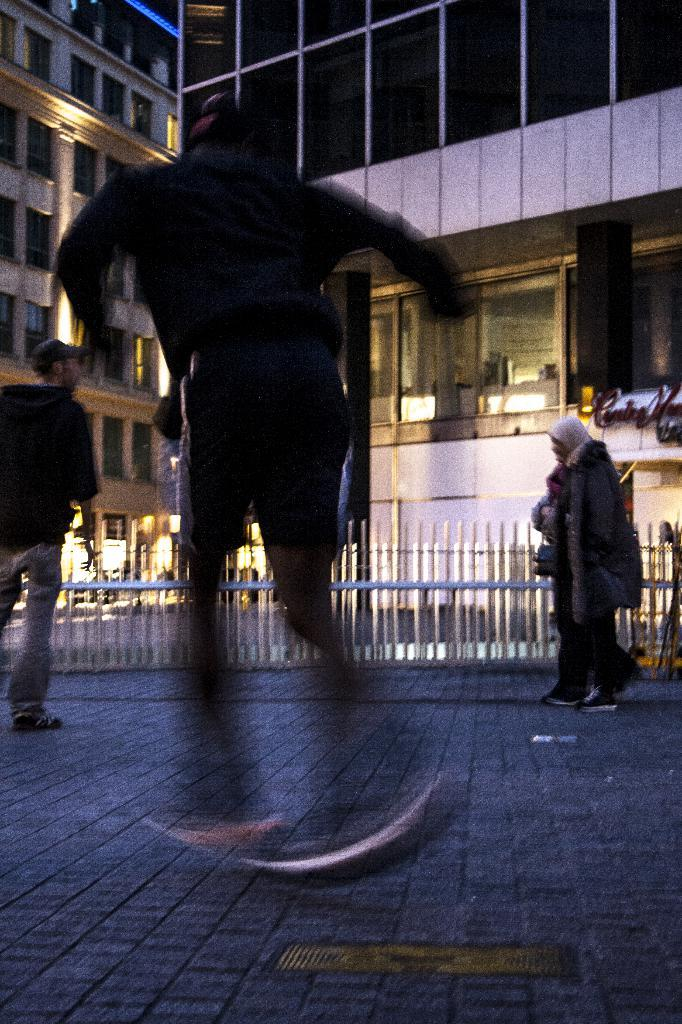Who or what is present in the image? There are people in the image. What can be seen in the distance behind the people? There are buildings in the background of the image. What architectural features are visible in the background? There are windows and fencing visible in the background of the image. What type of pancake can be seen growing in the park in the image? There is no park or pancake present in the image. 